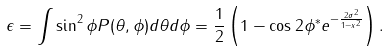<formula> <loc_0><loc_0><loc_500><loc_500>\epsilon = \int \sin ^ { 2 } \phi P ( \theta , \phi ) d \theta d \phi = \frac { 1 } { 2 } \left ( 1 - \cos 2 \phi ^ { * } e ^ { - \frac { 2 \sigma ^ { 2 } } { 1 - x ^ { 2 } } } \right ) .</formula> 